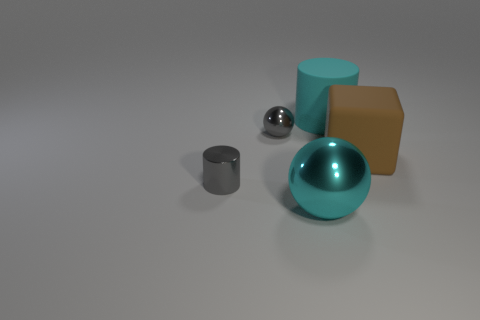Does the big cyan rubber thing have the same shape as the cyan metal thing?
Provide a succinct answer. No. There is a large cyan metallic thing; what shape is it?
Give a very brief answer. Sphere. There is a cyan rubber thing; does it have the same shape as the tiny shiny object that is behind the small gray cylinder?
Provide a short and direct response. No. Is the shape of the big rubber object on the right side of the cyan cylinder the same as  the big metal object?
Your response must be concise. No. How many objects are both in front of the cyan rubber thing and left of the brown block?
Give a very brief answer. 3. What number of other things are the same size as the gray metallic ball?
Provide a succinct answer. 1. Are there the same number of large metal balls that are in front of the gray metal ball and metallic balls?
Offer a terse response. No. There is a tiny metallic object in front of the large brown matte cube; is it the same color as the metallic ball that is in front of the gray metallic sphere?
Ensure brevity in your answer.  No. There is a object that is on the right side of the gray metallic sphere and left of the cyan matte cylinder; what is its material?
Your answer should be very brief. Metal. The tiny cylinder is what color?
Provide a short and direct response. Gray. 